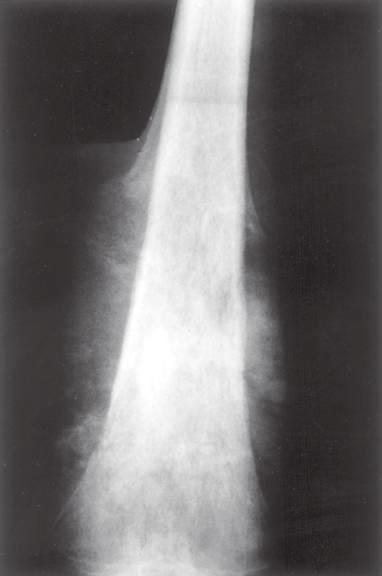has this abnormality laid down a triangular shell of reactive bone known as a codman triangle?
Answer the question using a single word or phrase. No 